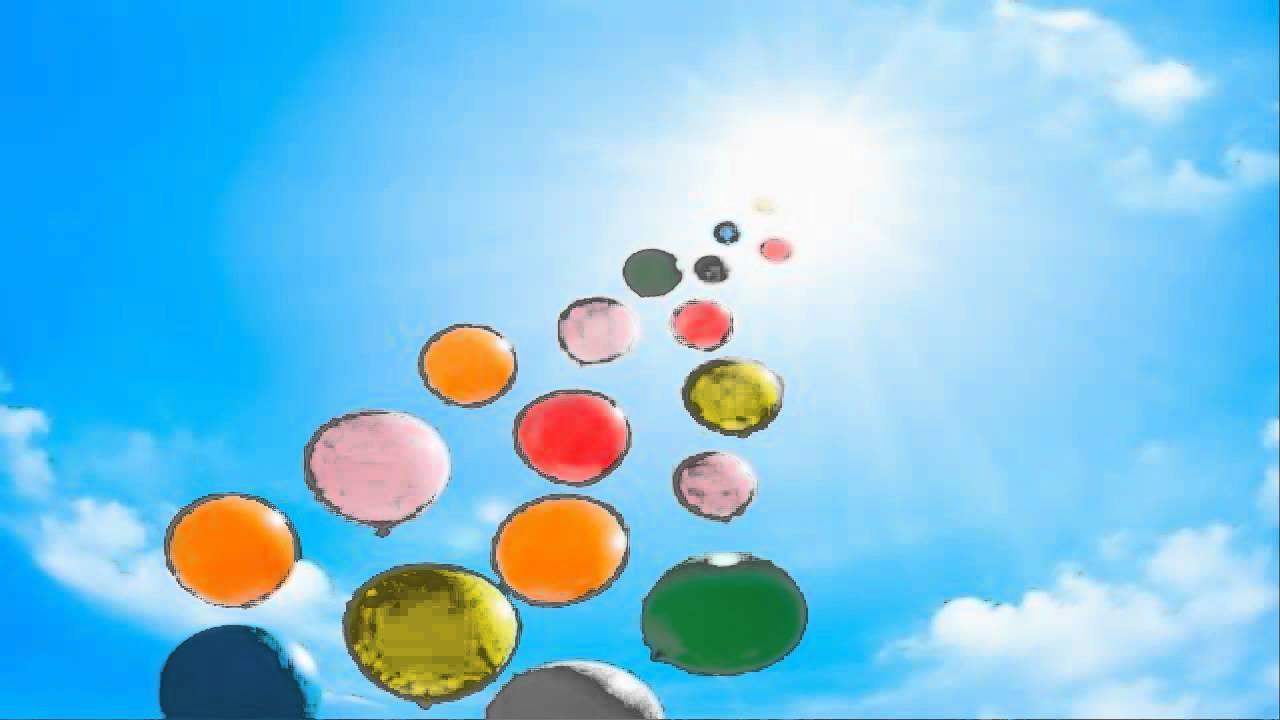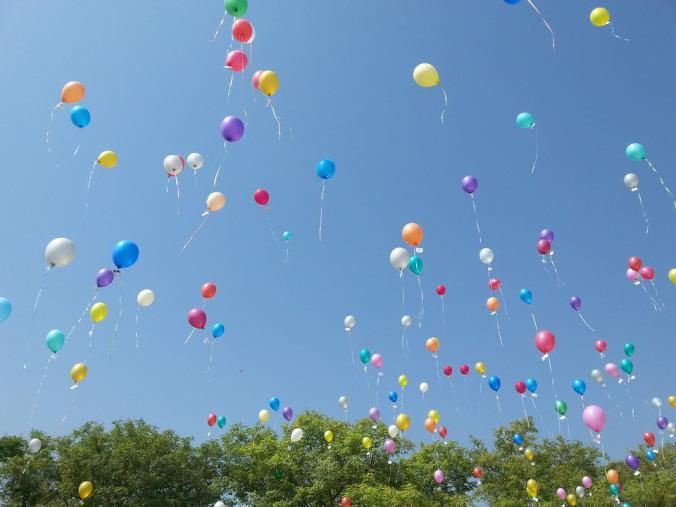The first image is the image on the left, the second image is the image on the right. Assess this claim about the two images: "There are no more than two balloons in the sky in the image on the right.". Correct or not? Answer yes or no. No. The first image is the image on the left, the second image is the image on the right. Evaluate the accuracy of this statement regarding the images: "The right image has no more than 2 balloons.". Is it true? Answer yes or no. No. 